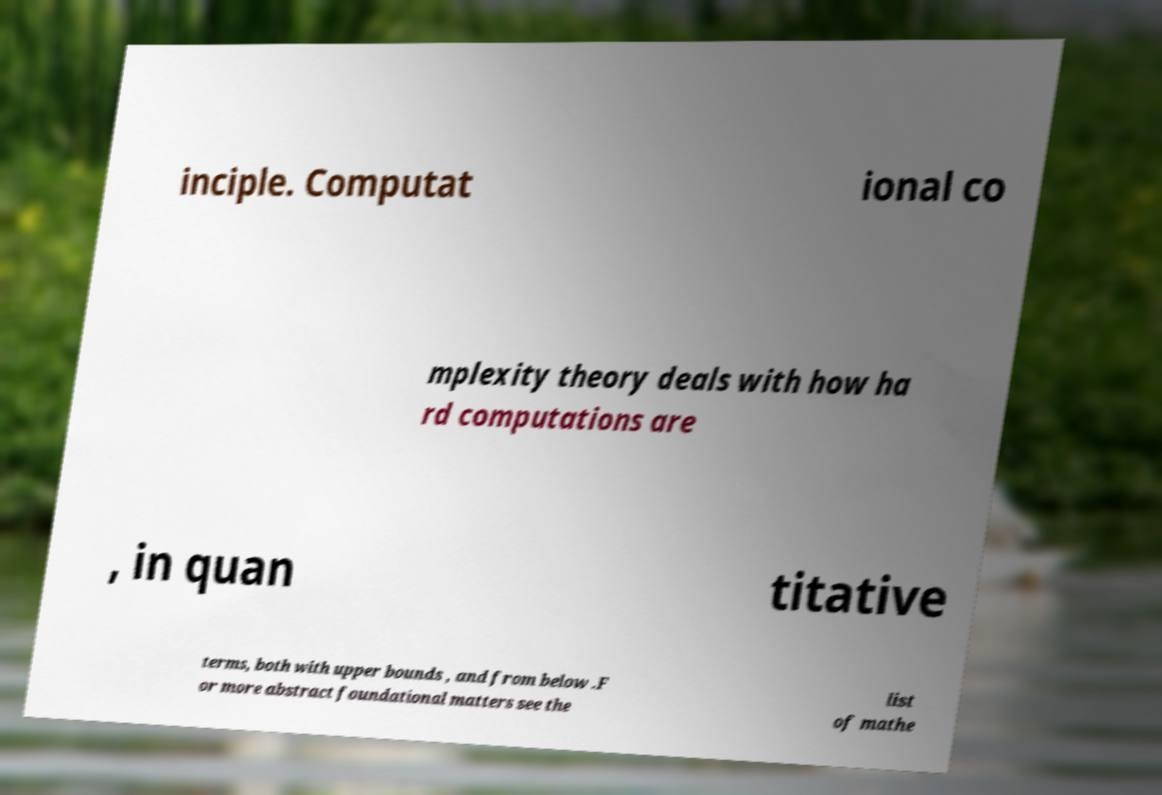Can you read and provide the text displayed in the image?This photo seems to have some interesting text. Can you extract and type it out for me? inciple. Computat ional co mplexity theory deals with how ha rd computations are , in quan titative terms, both with upper bounds , and from below .F or more abstract foundational matters see the list of mathe 